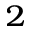Convert formula to latex. <formula><loc_0><loc_0><loc_500><loc_500>^ { 2 }</formula> 